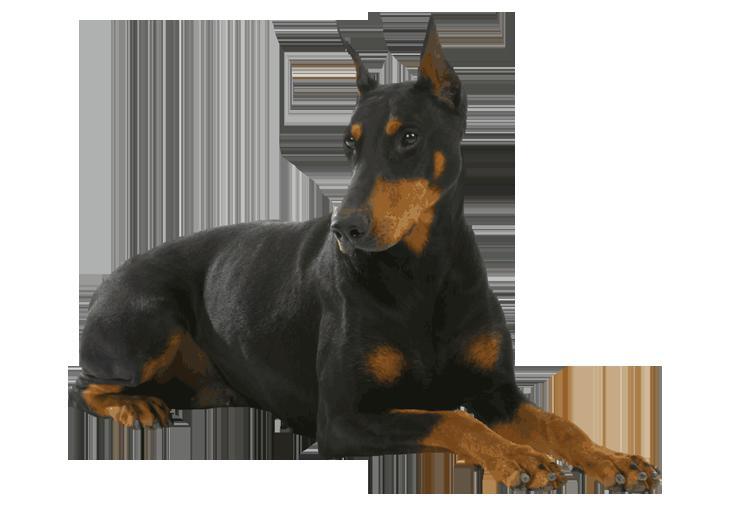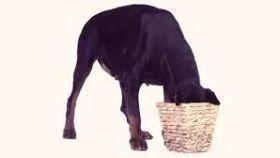The first image is the image on the left, the second image is the image on the right. For the images displayed, is the sentence "The left image shows a doberman wearing a collar, and the right image shows a doberman sitting upright without a collar on." factually correct? Answer yes or no. No. The first image is the image on the left, the second image is the image on the right. Considering the images on both sides, is "More than one doberman is sitting." valid? Answer yes or no. No. 